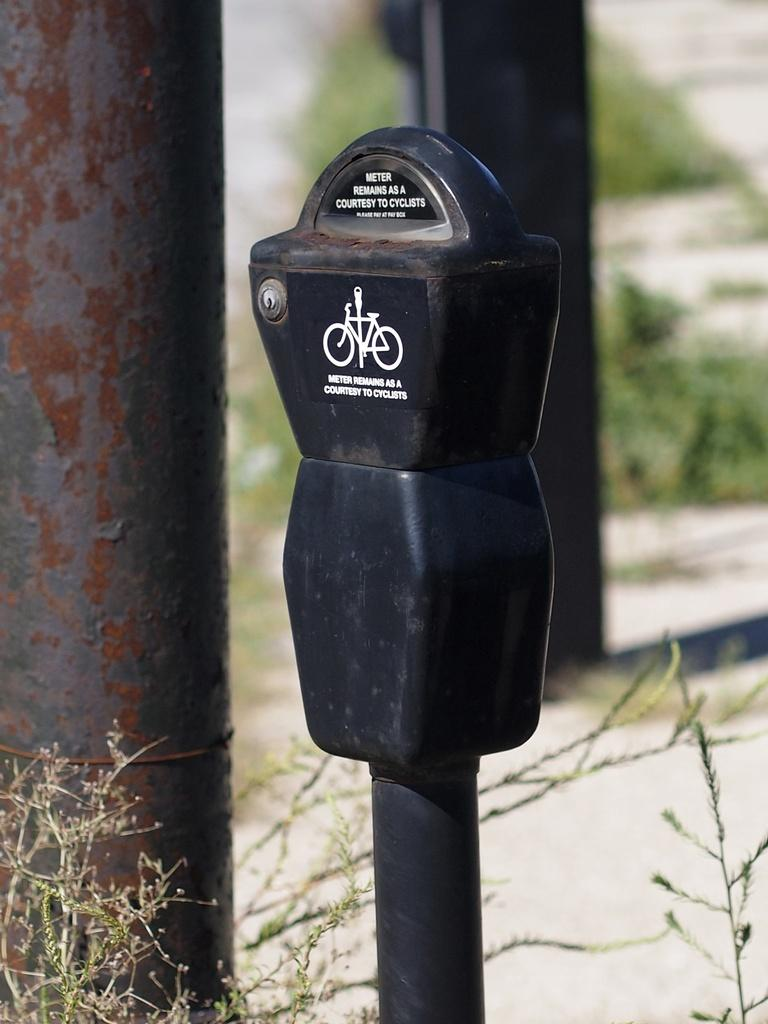What is the main object in the foreground of the image? There is a pole with a black meter in the image. Can you describe any other objects related to the main object? There is another pole behind the black meter. How would you describe the background of the image? The background of the image is blurred. How many chairs are placed around the cake in the image? There are no chairs or cake present in the image; it only features a pole with a black meter and another pole in the background. 